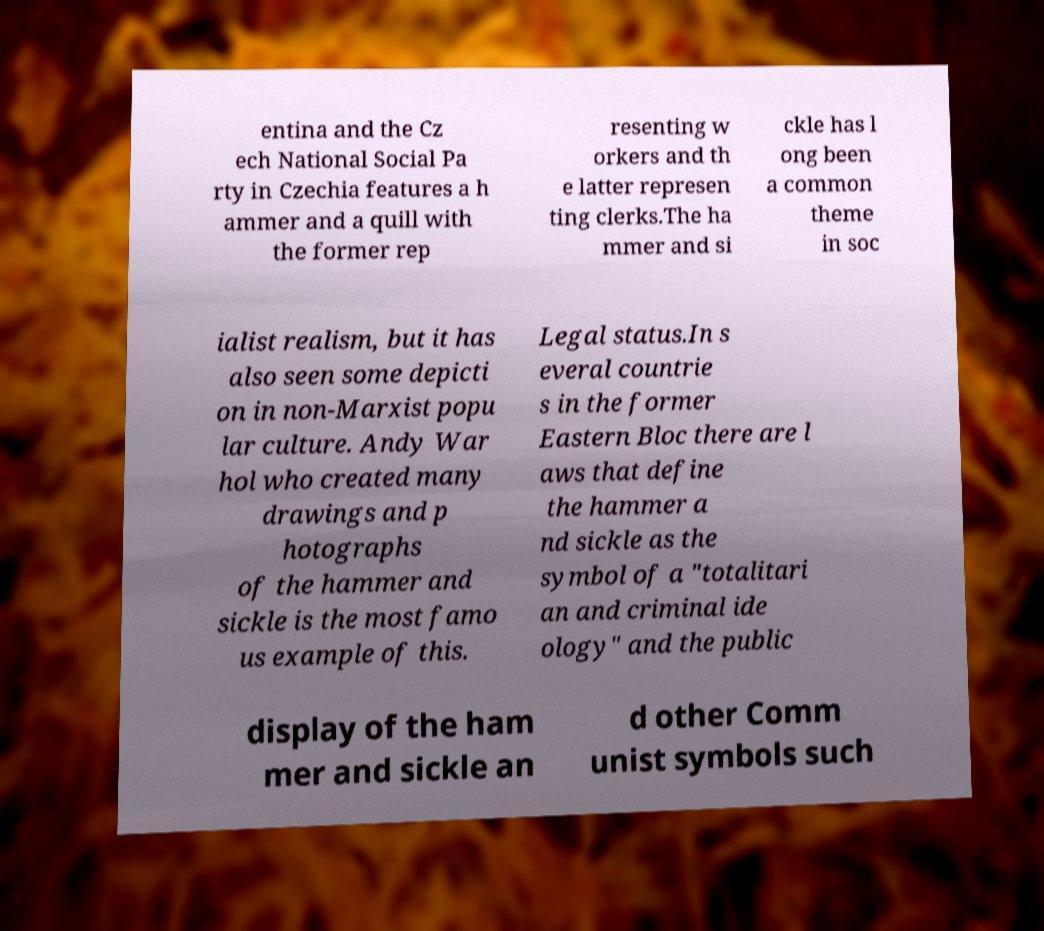I need the written content from this picture converted into text. Can you do that? entina and the Cz ech National Social Pa rty in Czechia features a h ammer and a quill with the former rep resenting w orkers and th e latter represen ting clerks.The ha mmer and si ckle has l ong been a common theme in soc ialist realism, but it has also seen some depicti on in non-Marxist popu lar culture. Andy War hol who created many drawings and p hotographs of the hammer and sickle is the most famo us example of this. Legal status.In s everal countrie s in the former Eastern Bloc there are l aws that define the hammer a nd sickle as the symbol of a "totalitari an and criminal ide ology" and the public display of the ham mer and sickle an d other Comm unist symbols such 